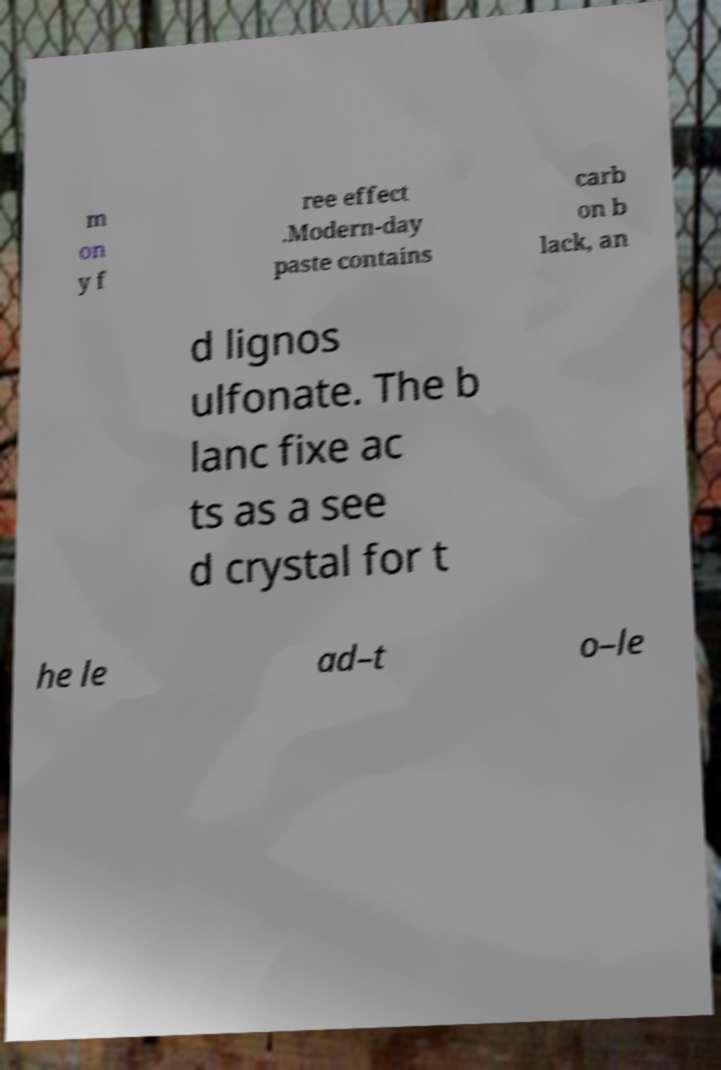I need the written content from this picture converted into text. Can you do that? m on y f ree effect .Modern-day paste contains carb on b lack, an d lignos ulfonate. The b lanc fixe ac ts as a see d crystal for t he le ad–t o–le 